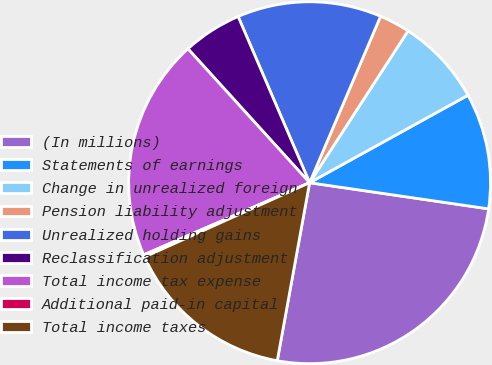Convert chart to OTSL. <chart><loc_0><loc_0><loc_500><loc_500><pie_chart><fcel>(In millions)<fcel>Statements of earnings<fcel>Change in unrealized foreign<fcel>Pension liability adjustment<fcel>Unrealized holding gains<fcel>Reclassification adjustment<fcel>Total income tax expense<fcel>Additional paid-in capital<fcel>Total income taxes<nl><fcel>25.55%<fcel>10.34%<fcel>7.81%<fcel>2.74%<fcel>12.88%<fcel>5.27%<fcel>19.79%<fcel>0.2%<fcel>15.41%<nl></chart> 